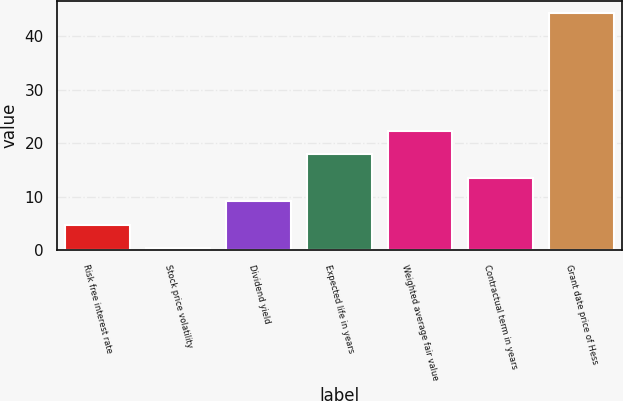Convert chart to OTSL. <chart><loc_0><loc_0><loc_500><loc_500><bar_chart><fcel>Risk free interest rate<fcel>Stock price volatility<fcel>Dividend yield<fcel>Expected life in years<fcel>Weighted average fair value<fcel>Contractual term in years<fcel>Grant date price of Hess<nl><fcel>4.73<fcel>0.33<fcel>9.13<fcel>17.93<fcel>22.33<fcel>13.53<fcel>44.31<nl></chart> 